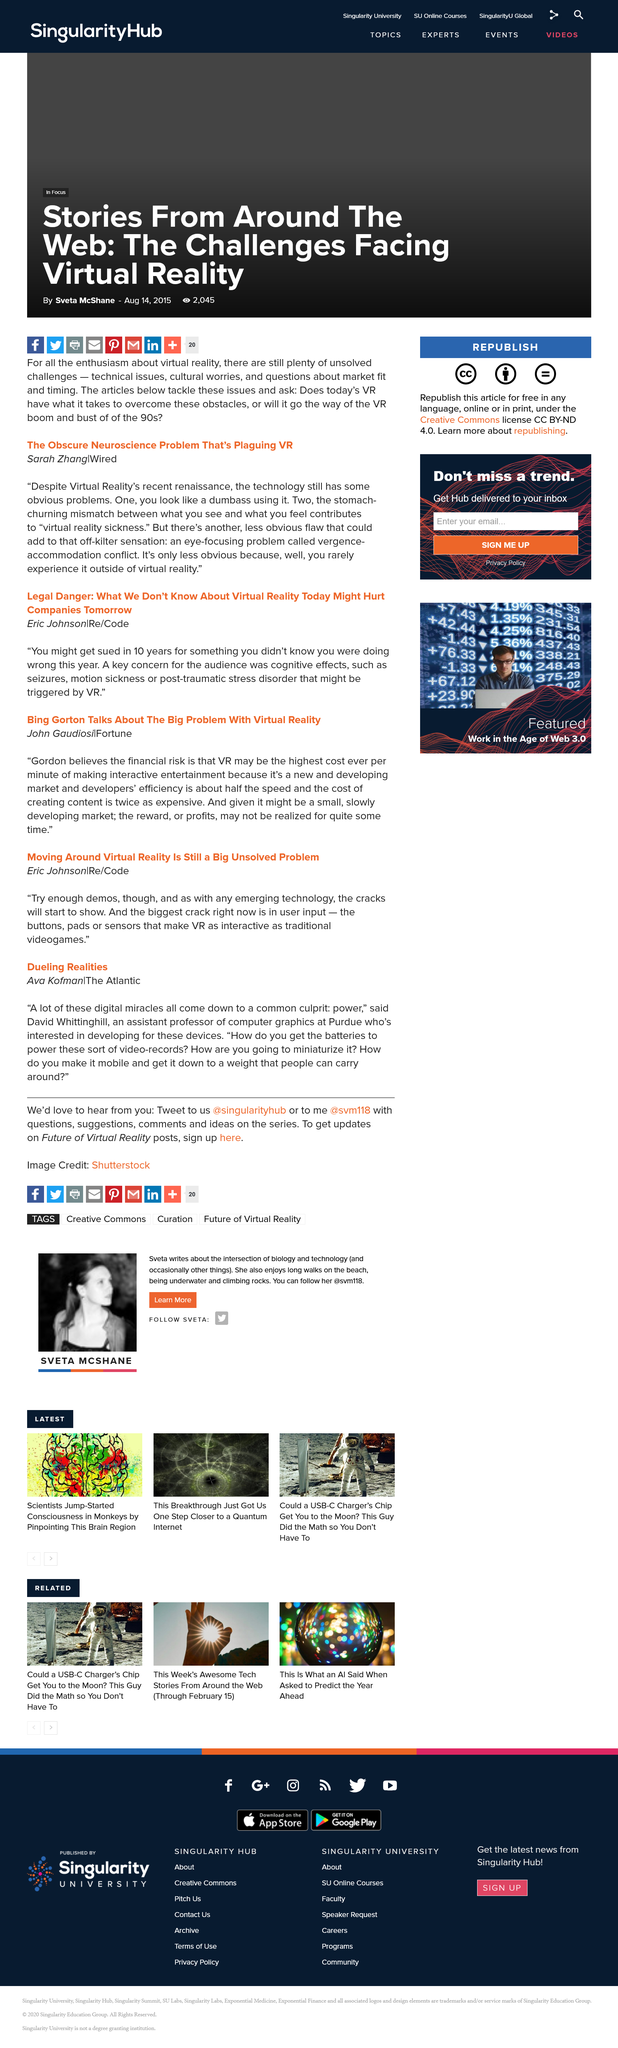Give some essential details in this illustration. It is evident that the user appears to be foolish and lacking intelligence. The reduction in developer efficiency is approximately half. Ava Kofman wrote "Dueling Realities. David Whittinghill holds the position of assistant professor of computer graphics at Purdue University. The surname of the author is Gaudiosi. 